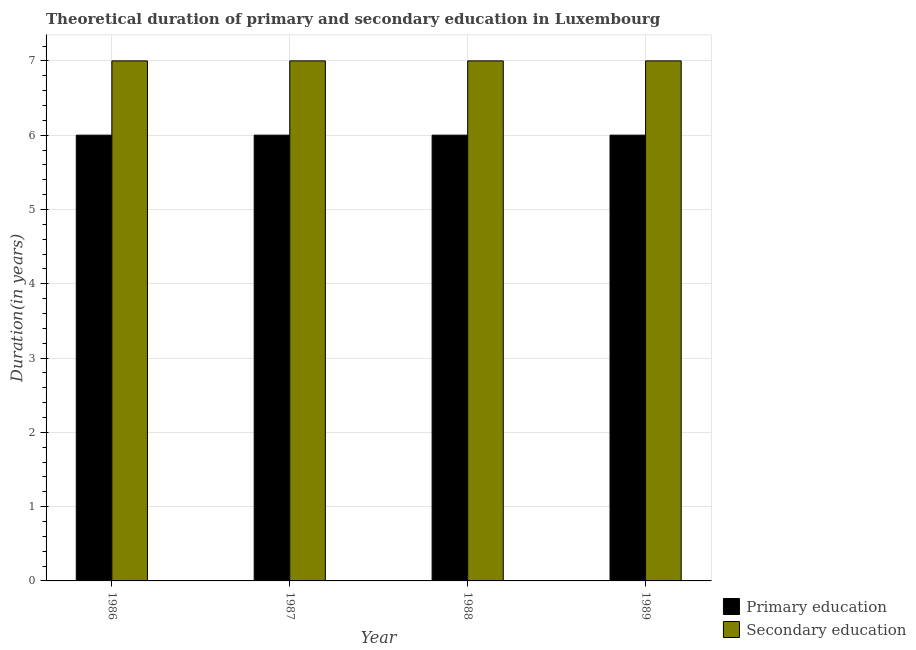How many different coloured bars are there?
Provide a succinct answer. 2. How many bars are there on the 2nd tick from the left?
Your answer should be very brief. 2. What is the label of the 3rd group of bars from the left?
Provide a short and direct response. 1988. Across all years, what is the maximum duration of secondary education?
Your response must be concise. 7. Across all years, what is the minimum duration of secondary education?
Provide a succinct answer. 7. What is the total duration of secondary education in the graph?
Offer a terse response. 28. What is the difference between the duration of secondary education in 1987 and that in 1988?
Ensure brevity in your answer.  0. What is the difference between the duration of secondary education in 1988 and the duration of primary education in 1986?
Make the answer very short. 0. What is the average duration of secondary education per year?
Offer a very short reply. 7. In the year 1986, what is the difference between the duration of secondary education and duration of primary education?
Keep it short and to the point. 0. Is the duration of primary education in 1987 less than that in 1988?
Your response must be concise. No. What is the difference between the highest and the second highest duration of secondary education?
Your answer should be compact. 0. What does the 2nd bar from the left in 1988 represents?
Your answer should be very brief. Secondary education. What does the 2nd bar from the right in 1987 represents?
Provide a succinct answer. Primary education. How many bars are there?
Keep it short and to the point. 8. Are all the bars in the graph horizontal?
Give a very brief answer. No. How many years are there in the graph?
Provide a succinct answer. 4. How many legend labels are there?
Offer a very short reply. 2. What is the title of the graph?
Make the answer very short. Theoretical duration of primary and secondary education in Luxembourg. What is the label or title of the X-axis?
Provide a short and direct response. Year. What is the label or title of the Y-axis?
Your answer should be very brief. Duration(in years). What is the Duration(in years) in Primary education in 1987?
Make the answer very short. 6. What is the Duration(in years) of Primary education in 1989?
Your response must be concise. 6. What is the Duration(in years) in Secondary education in 1989?
Give a very brief answer. 7. Across all years, what is the maximum Duration(in years) of Primary education?
Ensure brevity in your answer.  6. Across all years, what is the maximum Duration(in years) of Secondary education?
Provide a short and direct response. 7. Across all years, what is the minimum Duration(in years) in Secondary education?
Offer a terse response. 7. What is the total Duration(in years) of Primary education in the graph?
Give a very brief answer. 24. What is the difference between the Duration(in years) in Secondary education in 1986 and that in 1987?
Give a very brief answer. 0. What is the difference between the Duration(in years) of Primary education in 1986 and that in 1988?
Give a very brief answer. 0. What is the difference between the Duration(in years) of Primary education in 1986 and that in 1989?
Provide a short and direct response. 0. What is the difference between the Duration(in years) of Primary education in 1987 and that in 1988?
Your answer should be compact. 0. What is the difference between the Duration(in years) of Secondary education in 1987 and that in 1988?
Ensure brevity in your answer.  0. What is the difference between the Duration(in years) in Primary education in 1987 and that in 1989?
Give a very brief answer. 0. What is the difference between the Duration(in years) in Secondary education in 1987 and that in 1989?
Provide a short and direct response. 0. What is the difference between the Duration(in years) of Secondary education in 1988 and that in 1989?
Your answer should be very brief. 0. What is the difference between the Duration(in years) in Primary education in 1986 and the Duration(in years) in Secondary education in 1987?
Make the answer very short. -1. What is the difference between the Duration(in years) of Primary education in 1986 and the Duration(in years) of Secondary education in 1988?
Keep it short and to the point. -1. What is the difference between the Duration(in years) in Primary education in 1987 and the Duration(in years) in Secondary education in 1988?
Keep it short and to the point. -1. What is the difference between the Duration(in years) of Primary education in 1987 and the Duration(in years) of Secondary education in 1989?
Make the answer very short. -1. What is the average Duration(in years) in Primary education per year?
Your answer should be very brief. 6. What is the average Duration(in years) of Secondary education per year?
Provide a succinct answer. 7. In the year 1988, what is the difference between the Duration(in years) in Primary education and Duration(in years) in Secondary education?
Make the answer very short. -1. In the year 1989, what is the difference between the Duration(in years) of Primary education and Duration(in years) of Secondary education?
Your response must be concise. -1. What is the ratio of the Duration(in years) in Primary education in 1986 to that in 1987?
Your answer should be compact. 1. What is the ratio of the Duration(in years) of Primary education in 1986 to that in 1989?
Your answer should be compact. 1. What is the ratio of the Duration(in years) of Primary education in 1987 to that in 1989?
Provide a short and direct response. 1. What is the ratio of the Duration(in years) in Secondary education in 1987 to that in 1989?
Offer a terse response. 1. What is the ratio of the Duration(in years) of Primary education in 1988 to that in 1989?
Provide a short and direct response. 1. What is the ratio of the Duration(in years) in Secondary education in 1988 to that in 1989?
Provide a succinct answer. 1. What is the difference between the highest and the second highest Duration(in years) of Secondary education?
Your answer should be very brief. 0. What is the difference between the highest and the lowest Duration(in years) in Primary education?
Provide a succinct answer. 0. 